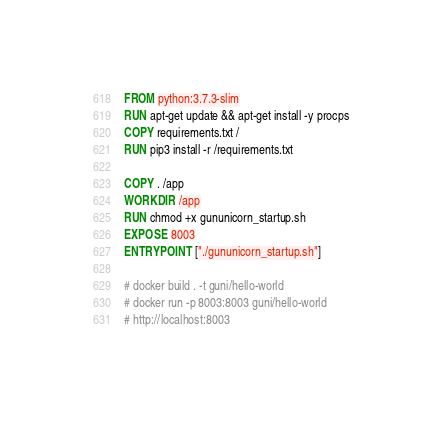Convert code to text. <code><loc_0><loc_0><loc_500><loc_500><_Dockerfile_>FROM python:3.7.3-slim
RUN apt-get update && apt-get install -y procps
COPY requirements.txt /
RUN pip3 install -r /requirements.txt

COPY . /app
WORKDIR /app
RUN chmod +x gununicorn_startup.sh 
EXPOSE 8003
ENTRYPOINT ["./gununicorn_startup.sh"]

# docker build . -t guni/hello-world
# docker run -p 8003:8003 guni/hello-world
# http://localhost:8003</code> 